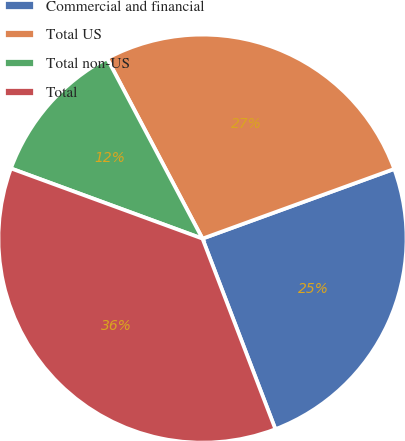Convert chart to OTSL. <chart><loc_0><loc_0><loc_500><loc_500><pie_chart><fcel>Commercial and financial<fcel>Total US<fcel>Total non-US<fcel>Total<nl><fcel>24.73%<fcel>27.2%<fcel>11.66%<fcel>36.41%<nl></chart> 